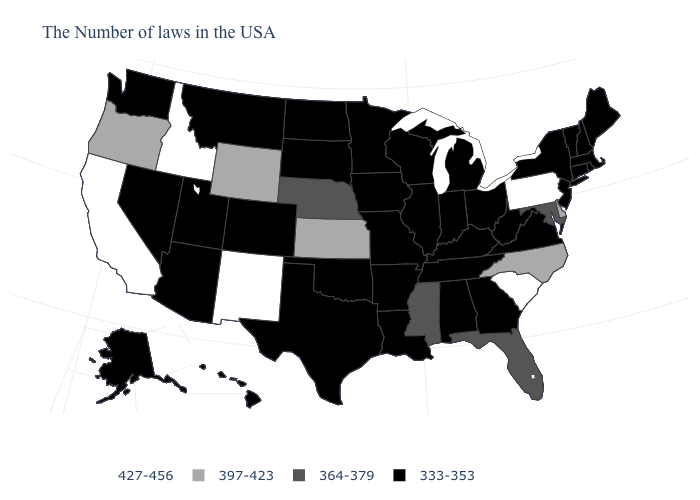Is the legend a continuous bar?
Write a very short answer. No. Among the states that border New Jersey , which have the highest value?
Quick response, please. Pennsylvania. What is the value of Florida?
Answer briefly. 364-379. What is the highest value in the USA?
Write a very short answer. 427-456. Which states have the highest value in the USA?
Keep it brief. Pennsylvania, South Carolina, New Mexico, Idaho, California. What is the value of California?
Quick response, please. 427-456. Which states have the lowest value in the Northeast?
Be succinct. Maine, Massachusetts, Rhode Island, New Hampshire, Vermont, Connecticut, New York, New Jersey. What is the highest value in the Northeast ?
Concise answer only. 427-456. Which states have the lowest value in the USA?
Keep it brief. Maine, Massachusetts, Rhode Island, New Hampshire, Vermont, Connecticut, New York, New Jersey, Virginia, West Virginia, Ohio, Georgia, Michigan, Kentucky, Indiana, Alabama, Tennessee, Wisconsin, Illinois, Louisiana, Missouri, Arkansas, Minnesota, Iowa, Oklahoma, Texas, South Dakota, North Dakota, Colorado, Utah, Montana, Arizona, Nevada, Washington, Alaska, Hawaii. What is the value of West Virginia?
Answer briefly. 333-353. Among the states that border North Carolina , does Tennessee have the highest value?
Keep it brief. No. What is the lowest value in the USA?
Be succinct. 333-353. Name the states that have a value in the range 364-379?
Be succinct. Maryland, Florida, Mississippi, Nebraska. Name the states that have a value in the range 397-423?
Answer briefly. Delaware, North Carolina, Kansas, Wyoming, Oregon. Name the states that have a value in the range 364-379?
Short answer required. Maryland, Florida, Mississippi, Nebraska. 